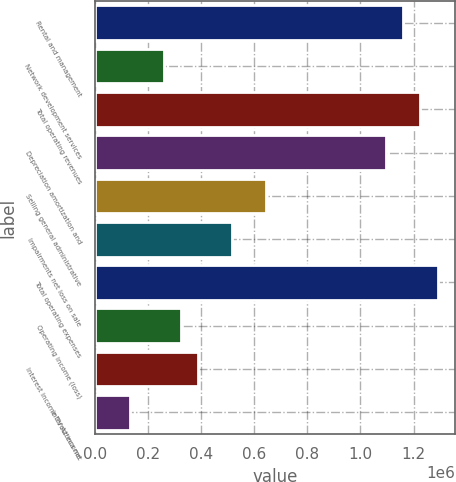<chart> <loc_0><loc_0><loc_500><loc_500><bar_chart><fcel>Rental and management<fcel>Network development services<fcel>Total operating revenues<fcel>Depreciation amortization and<fcel>Selling general administrative<fcel>Impairments net loss on sale<fcel>Total operating expenses<fcel>Operating income (loss)<fcel>Interest income TV Azteca net<fcel>Interest income<nl><fcel>1.16165e+06<fcel>258145<fcel>1.22618e+06<fcel>1.09711e+06<fcel>645361<fcel>516289<fcel>1.29072e+06<fcel>322681<fcel>387217<fcel>129073<nl></chart> 